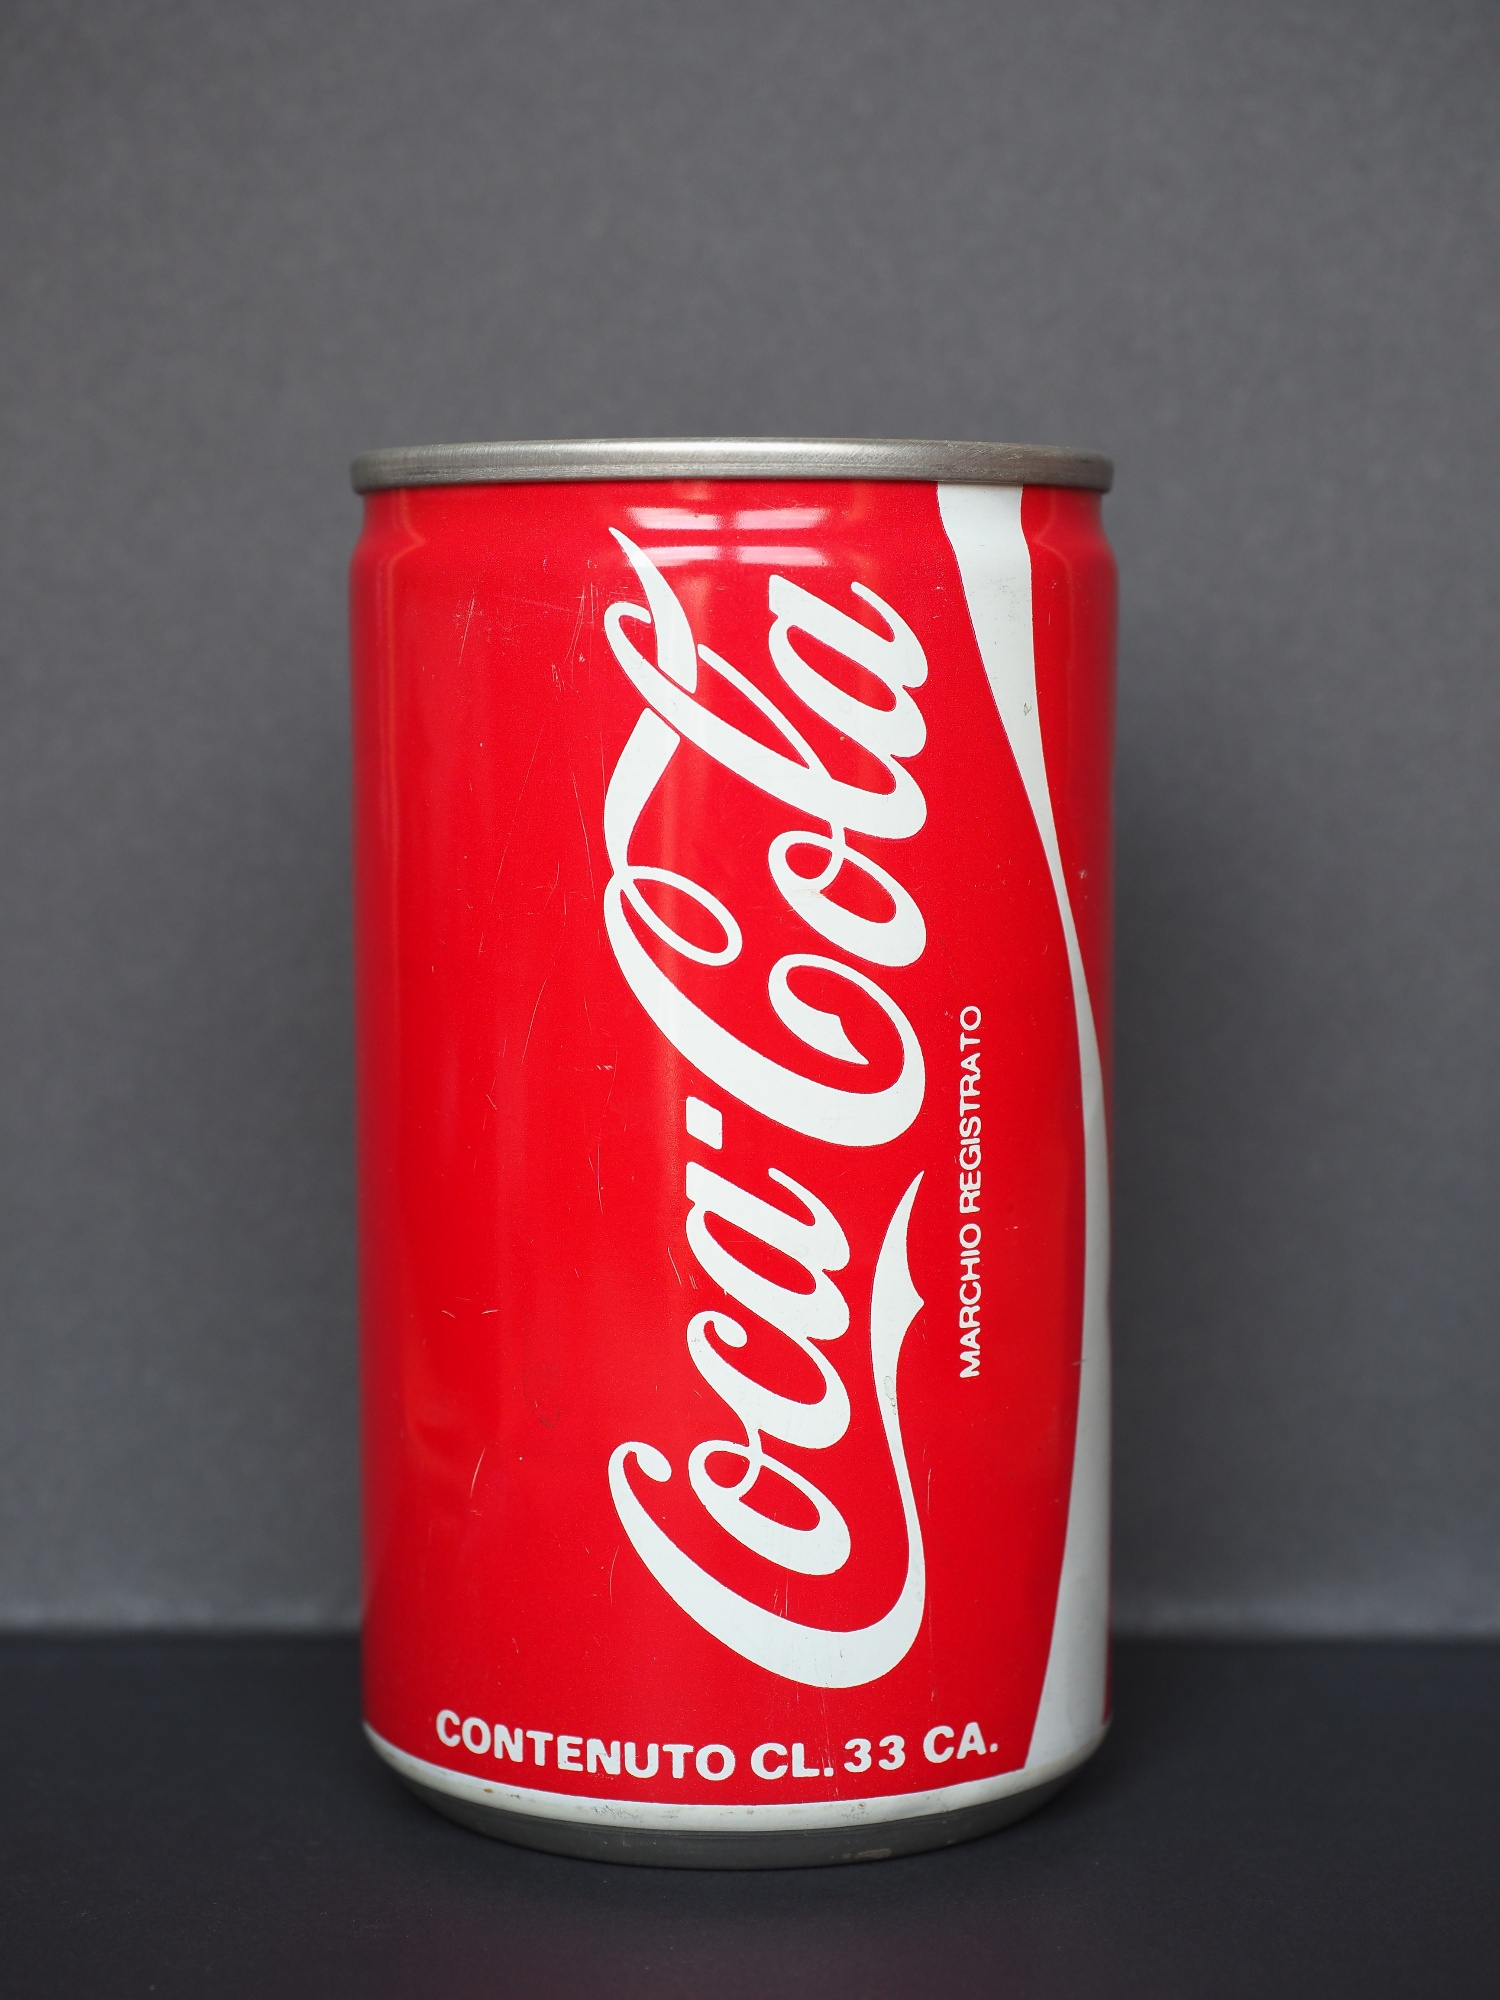What is this photo about'? The image captures a standard-sized Coca Cola can, prominently positioned upright on a gray surface. The can, unmistakably recognized by its vibrant red color and iconic white Coca Cola logo, appears unopened with a silver top. The Italian text on the can, 'Contenuto cl. 33 ca.' and 'Marchio registrato', translates to 'Content approx. 33 cl.' and 'Registered trademark' respectively, adding a touch of international flair. The simple yet striking composition, with the can centered against a darker gray backdrop, effectively draws the viewer’s focus, highlighting the can as the central subject of the photograph. 